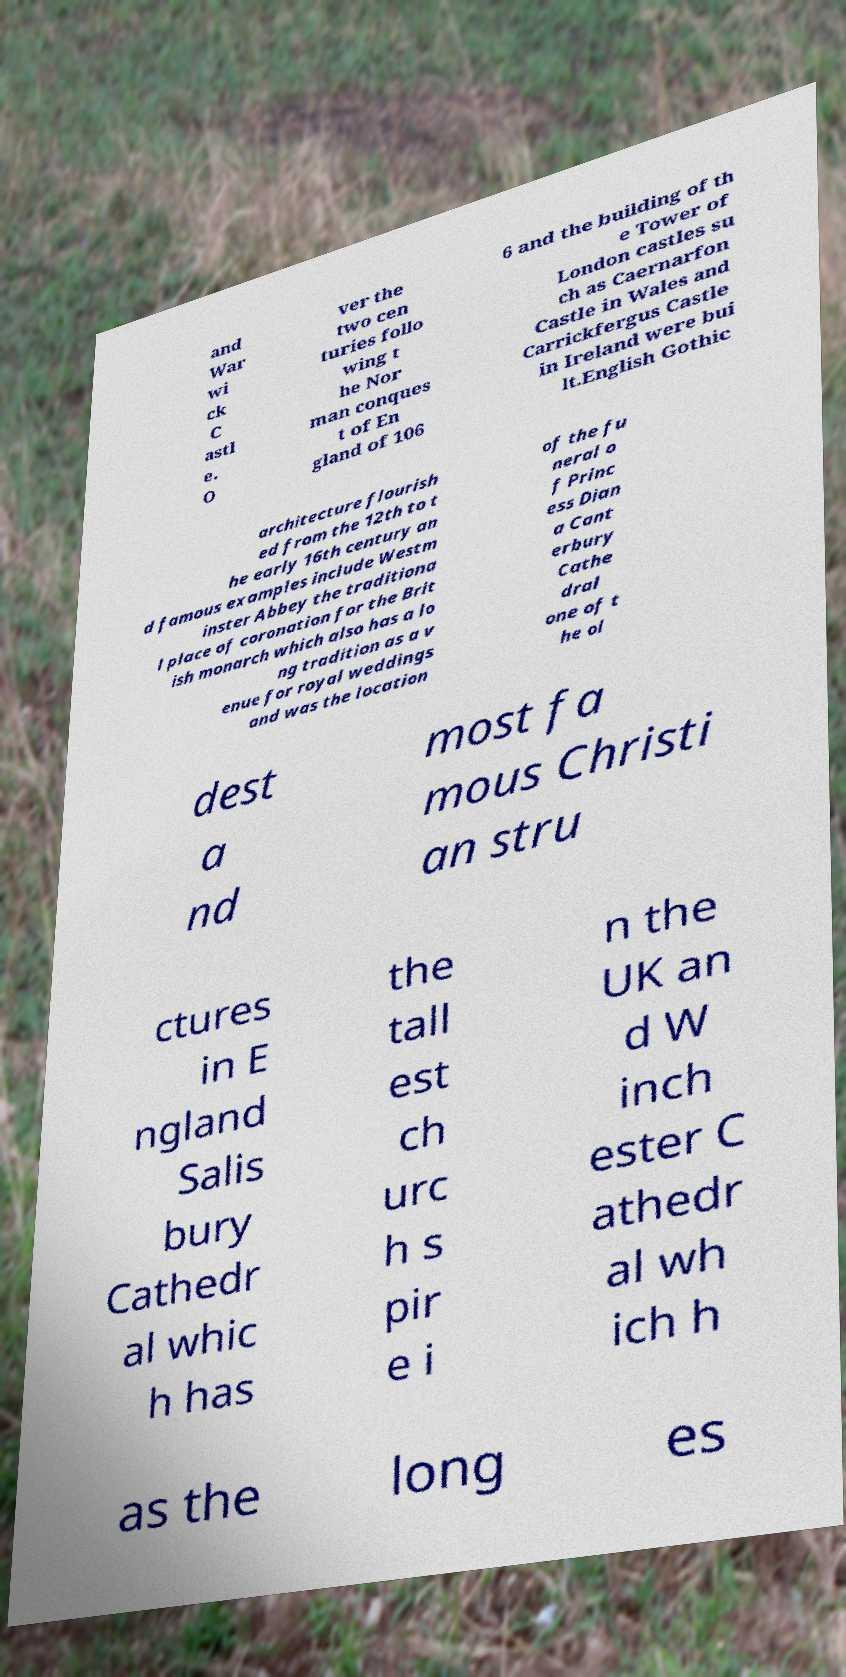I need the written content from this picture converted into text. Can you do that? and War wi ck C astl e. O ver the two cen turies follo wing t he Nor man conques t of En gland of 106 6 and the building of th e Tower of London castles su ch as Caernarfon Castle in Wales and Carrickfergus Castle in Ireland were bui lt.English Gothic architecture flourish ed from the 12th to t he early 16th century an d famous examples include Westm inster Abbey the traditiona l place of coronation for the Brit ish monarch which also has a lo ng tradition as a v enue for royal weddings and was the location of the fu neral o f Princ ess Dian a Cant erbury Cathe dral one of t he ol dest a nd most fa mous Christi an stru ctures in E ngland Salis bury Cathedr al whic h has the tall est ch urc h s pir e i n the UK an d W inch ester C athedr al wh ich h as the long es 